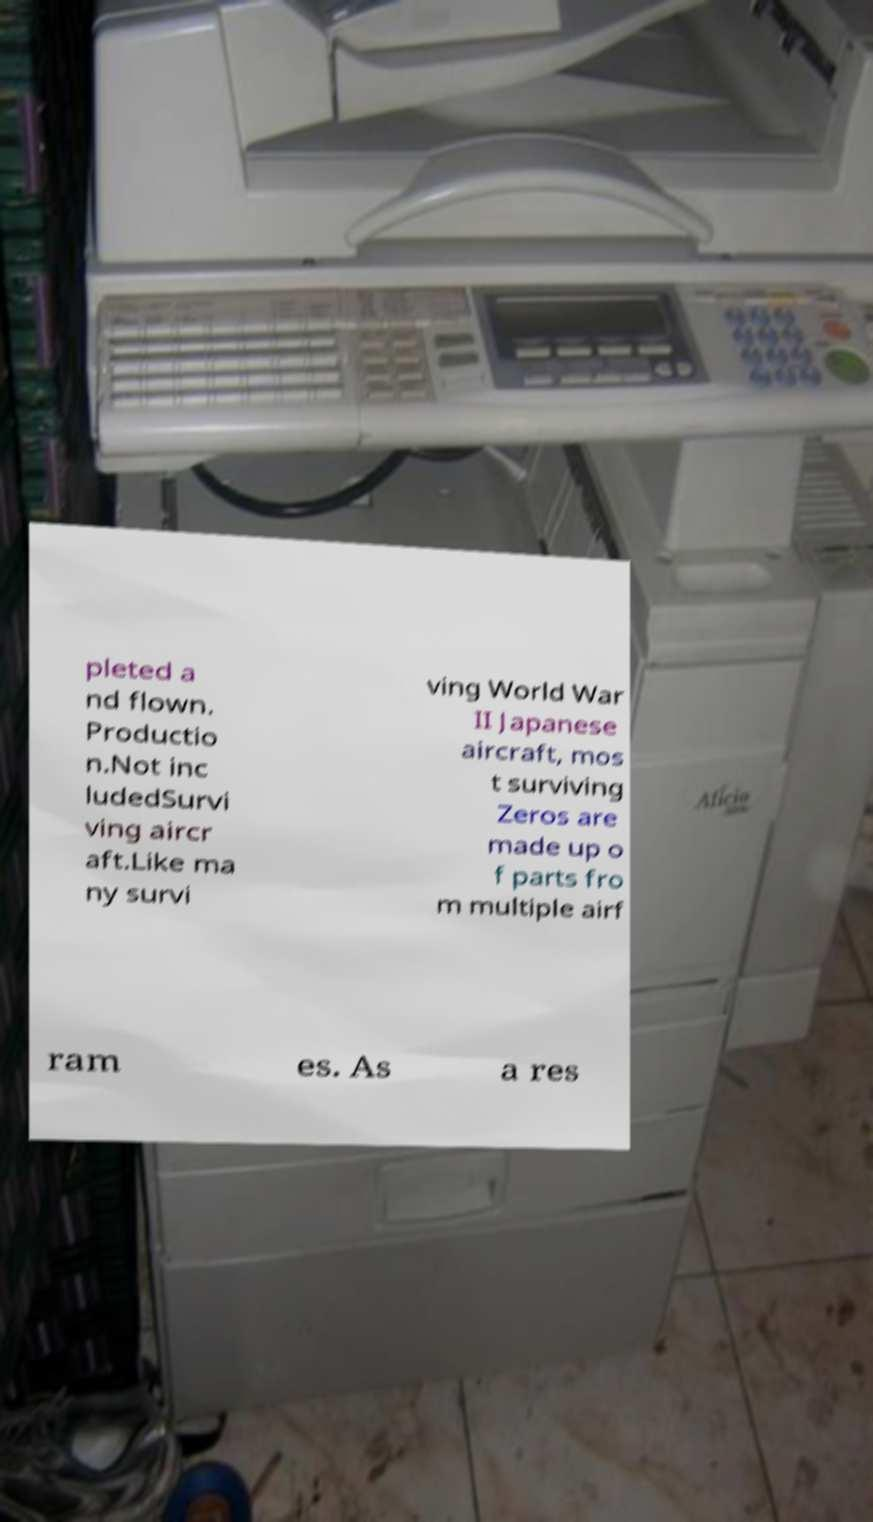There's text embedded in this image that I need extracted. Can you transcribe it verbatim? pleted a nd flown. Productio n.Not inc ludedSurvi ving aircr aft.Like ma ny survi ving World War II Japanese aircraft, mos t surviving Zeros are made up o f parts fro m multiple airf ram es. As a res 